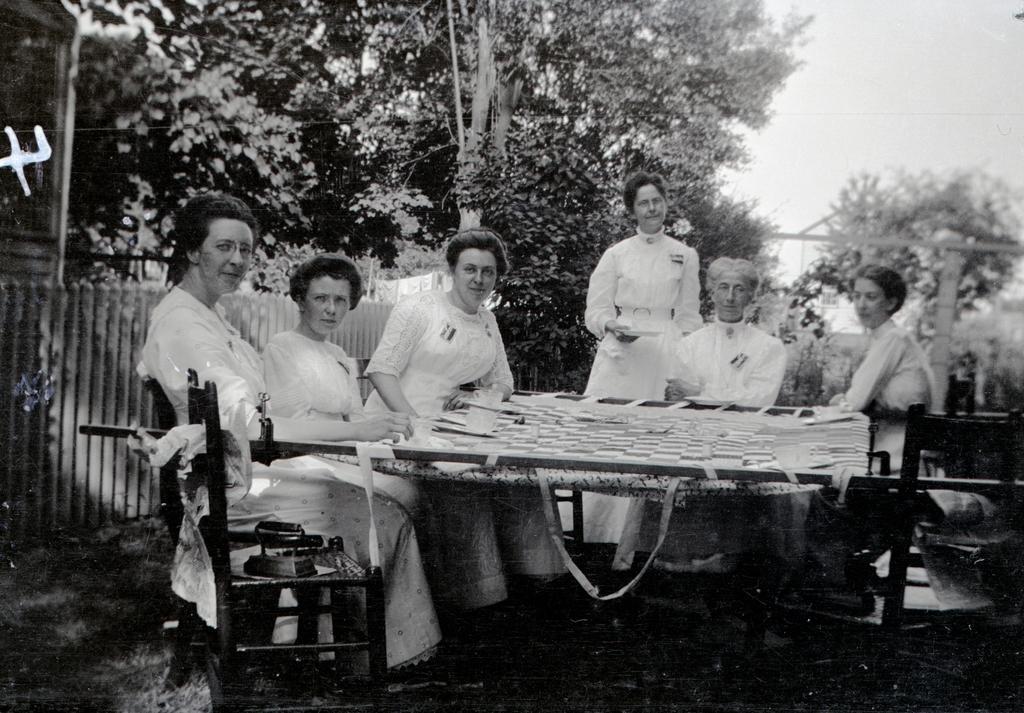Could you give a brief overview of what you see in this image? In this image i can see 6 women, 5 of them are sitting and one of them is standing and i can see a railing and in the background i can see trees and a sky. 